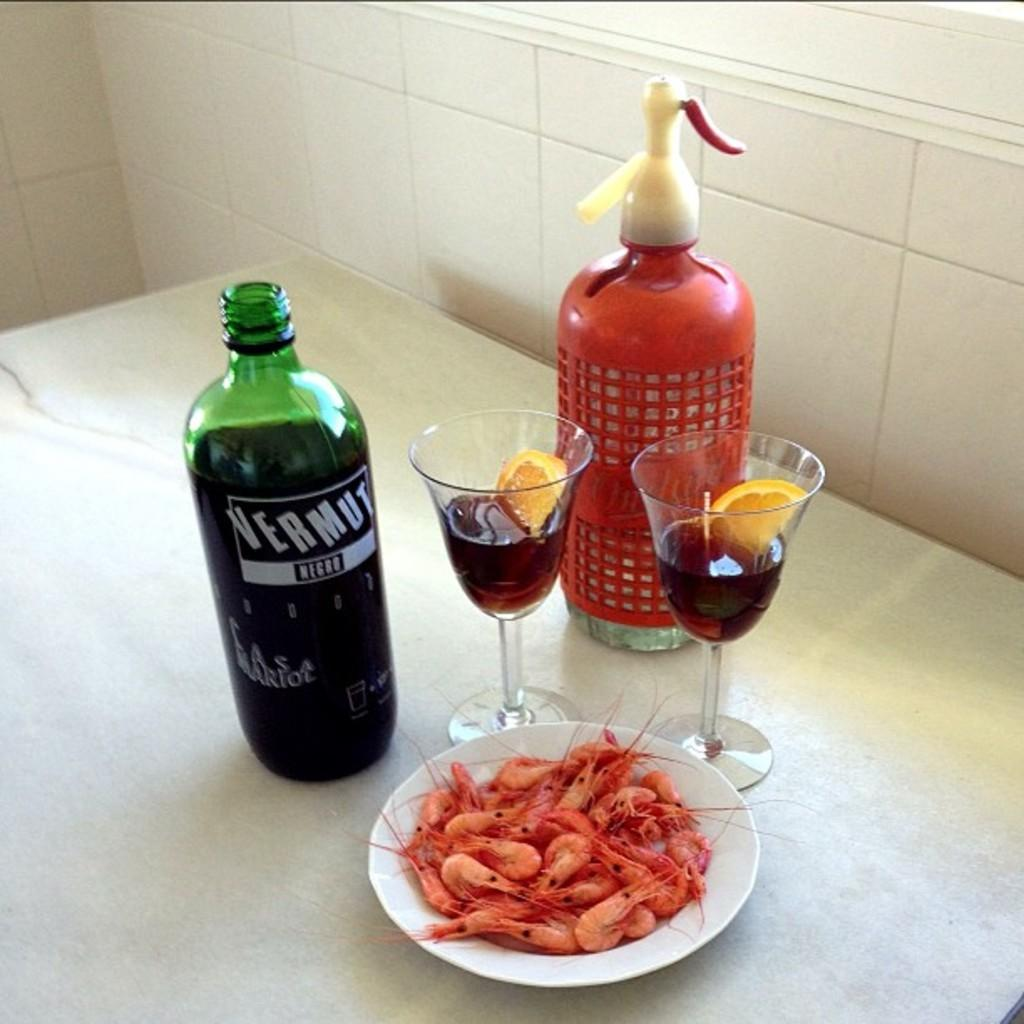What type of table is in the image? There is a white table in the image. What is on the table? There are items placed on the table. What can be seen in the background of the image? The background of the image includes tile walls. What type of rifle can be seen in the image? There is no rifle present in the image. What type of harmony is being played in the image? There is no music or harmony being played in the image. 